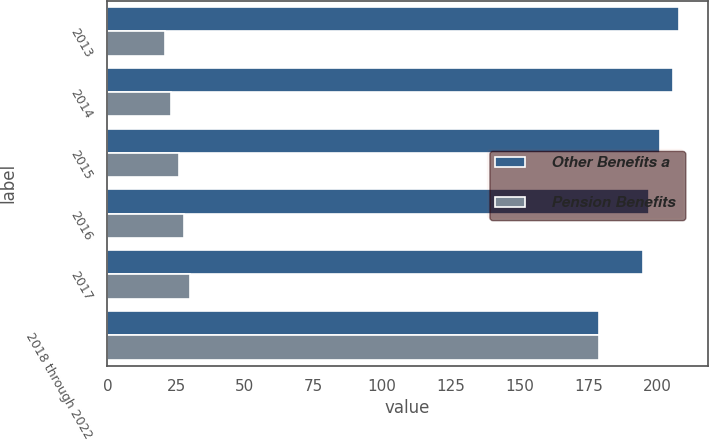<chart> <loc_0><loc_0><loc_500><loc_500><stacked_bar_chart><ecel><fcel>2013<fcel>2014<fcel>2015<fcel>2016<fcel>2017<fcel>2018 through 2022<nl><fcel>Other Benefits a<fcel>208<fcel>206<fcel>201<fcel>197<fcel>195<fcel>179<nl><fcel>Pension Benefits<fcel>21<fcel>23<fcel>26<fcel>28<fcel>30<fcel>179<nl></chart> 